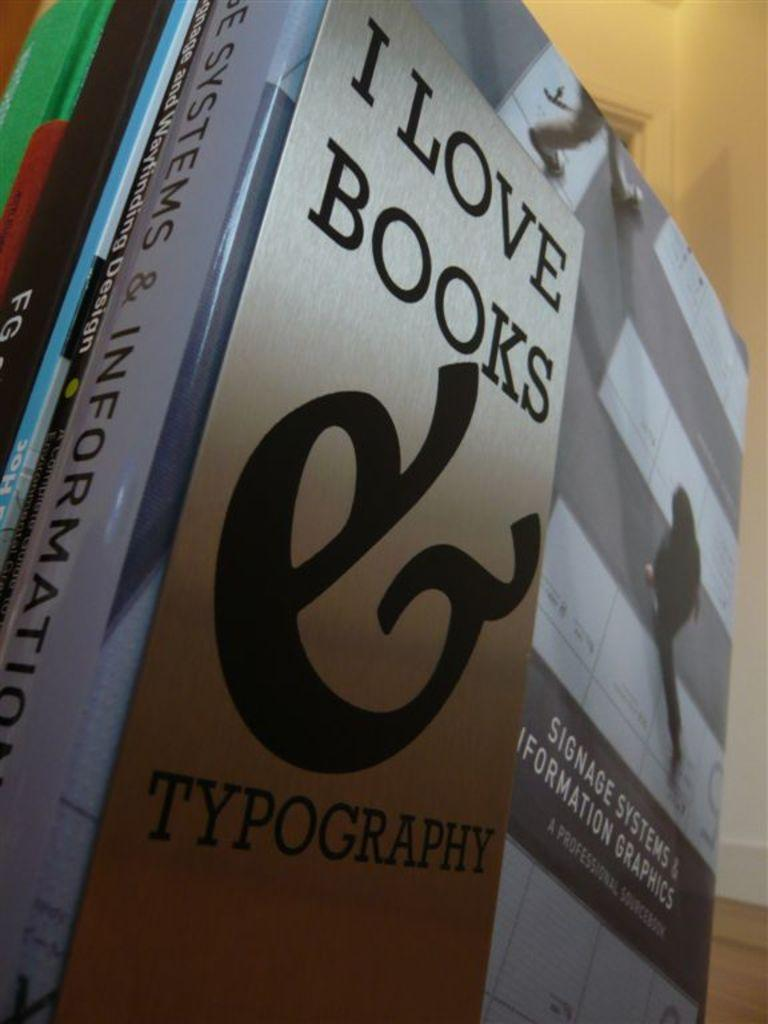<image>
Write a terse but informative summary of the picture. A bookmark for a person who loves books sitting on top of a stack of books. 